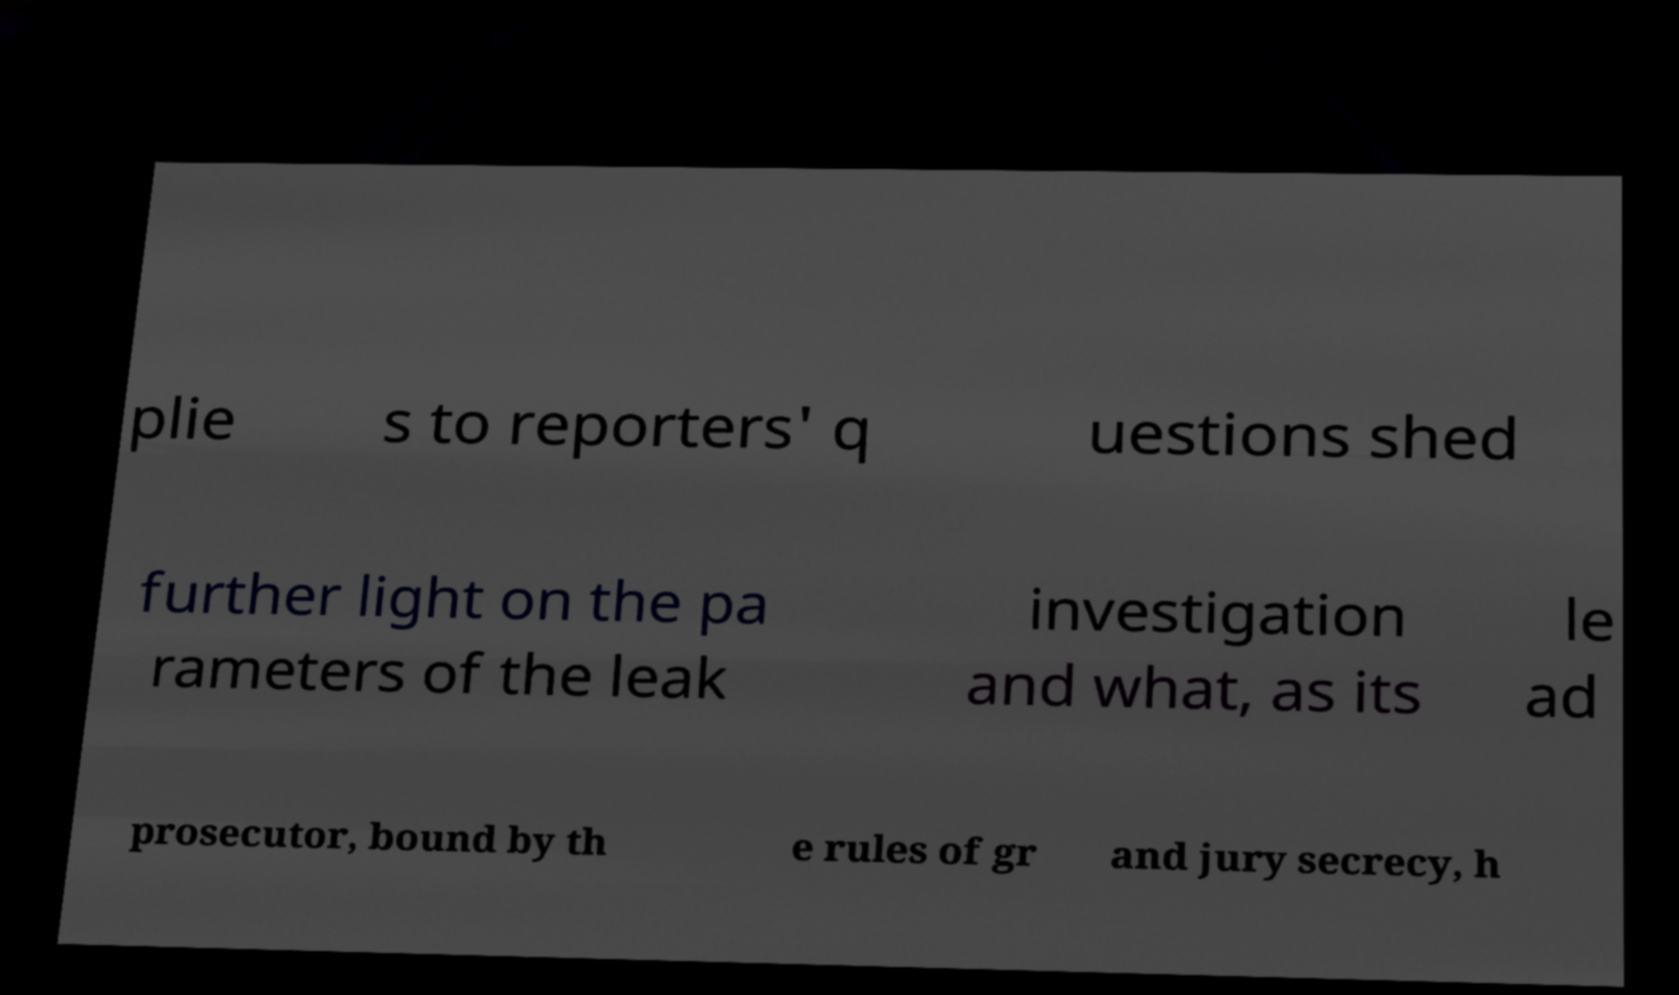I need the written content from this picture converted into text. Can you do that? plie s to reporters' q uestions shed further light on the pa rameters of the leak investigation and what, as its le ad prosecutor, bound by th e rules of gr and jury secrecy, h 